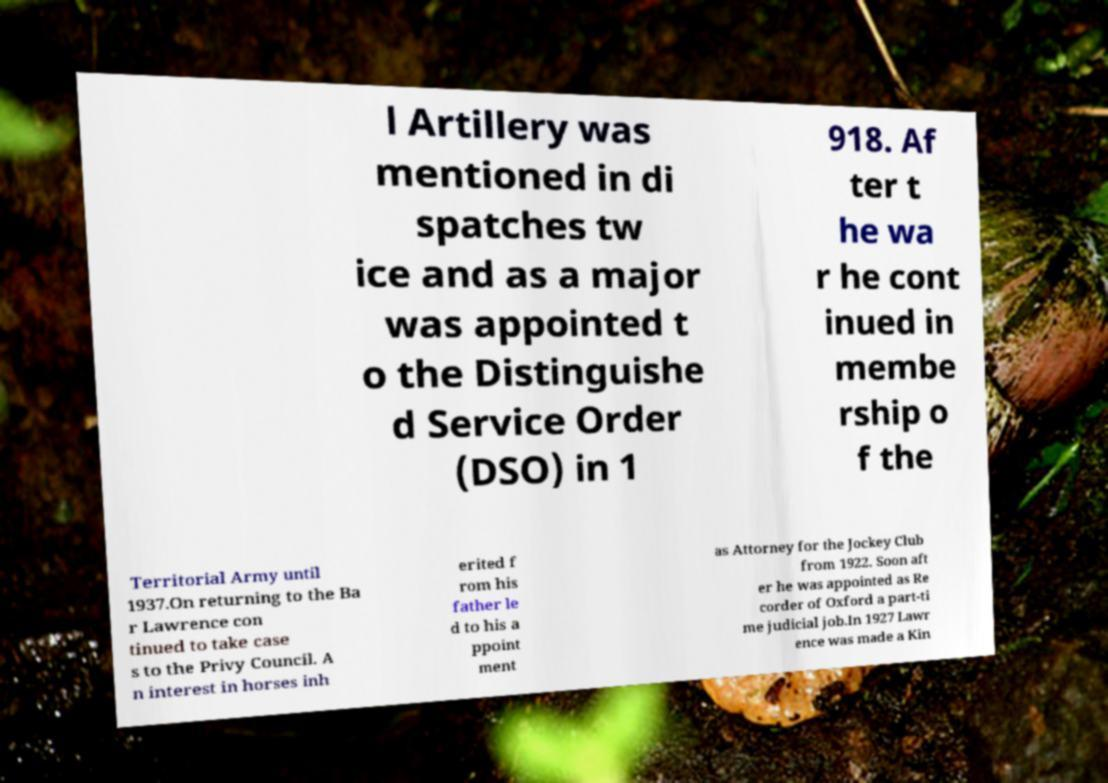For documentation purposes, I need the text within this image transcribed. Could you provide that? l Artillery was mentioned in di spatches tw ice and as a major was appointed t o the Distinguishe d Service Order (DSO) in 1 918. Af ter t he wa r he cont inued in membe rship o f the Territorial Army until 1937.On returning to the Ba r Lawrence con tinued to take case s to the Privy Council. A n interest in horses inh erited f rom his father le d to his a ppoint ment as Attorney for the Jockey Club from 1922. Soon aft er he was appointed as Re corder of Oxford a part-ti me judicial job.In 1927 Lawr ence was made a Kin 